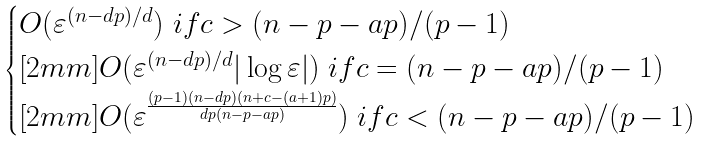<formula> <loc_0><loc_0><loc_500><loc_500>\begin{cases} O ( \varepsilon ^ { ( n - d p ) / d } ) \ i f c > ( n - p - a p ) / ( p - 1 ) \\ [ 2 m m ] O ( \varepsilon ^ { ( n - d p ) / d } | \log \varepsilon | ) \ i f c = ( n - p - a p ) / ( p - 1 ) \\ [ 2 m m ] O ( \varepsilon ^ { \frac { ( p - 1 ) ( n - d p ) ( n + c - ( a + 1 ) p ) } { d p ( n - p - a p ) } } ) \ i f c < ( n - p - a p ) / ( p - 1 ) \end{cases}</formula> 